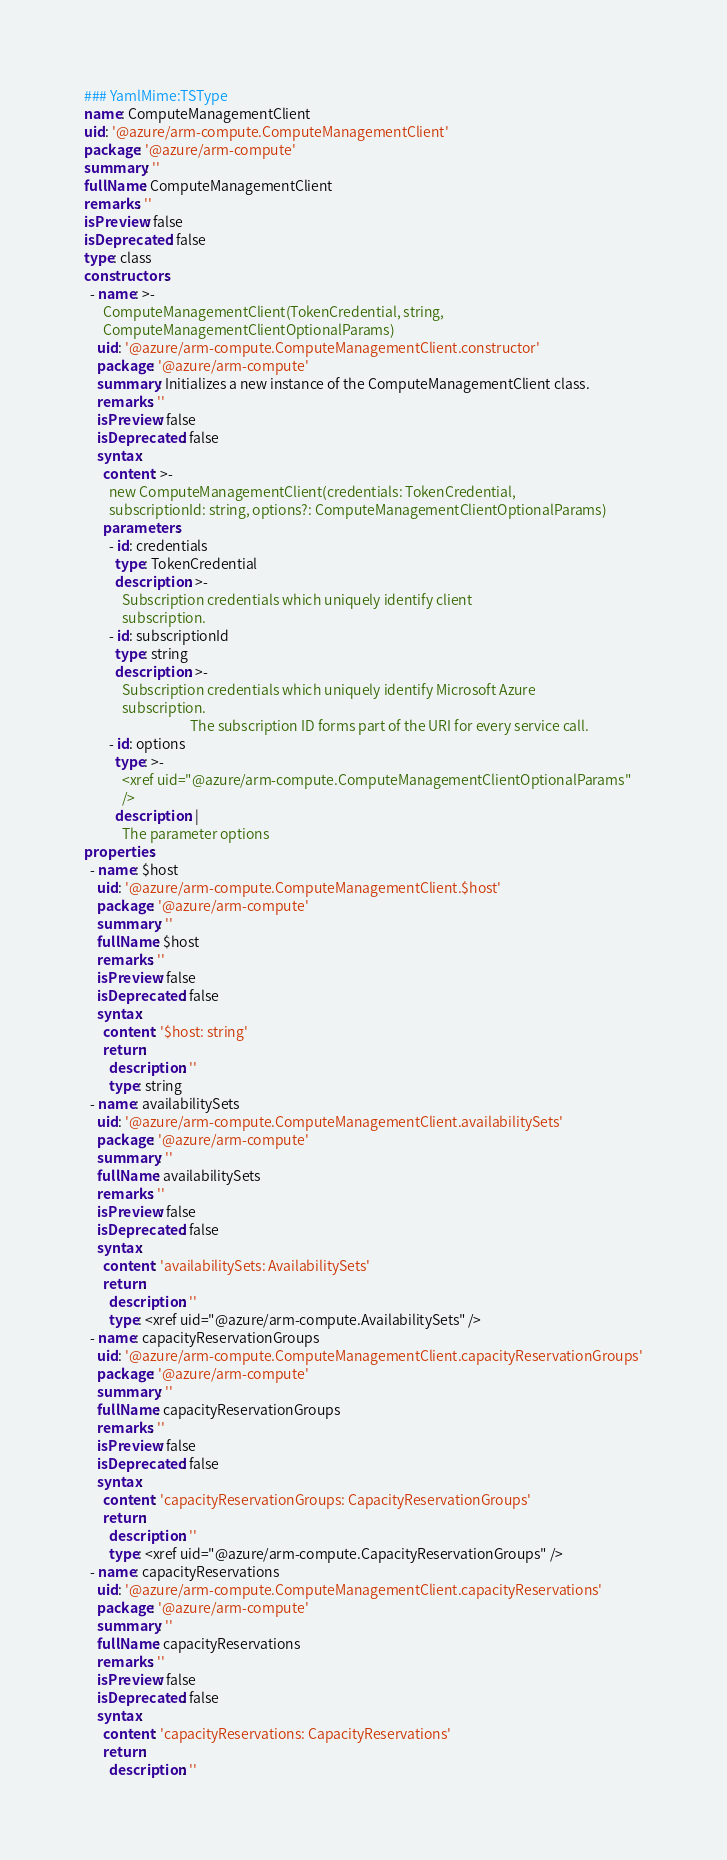Convert code to text. <code><loc_0><loc_0><loc_500><loc_500><_YAML_>### YamlMime:TSType
name: ComputeManagementClient
uid: '@azure/arm-compute.ComputeManagementClient'
package: '@azure/arm-compute'
summary: ''
fullName: ComputeManagementClient
remarks: ''
isPreview: false
isDeprecated: false
type: class
constructors:
  - name: >-
      ComputeManagementClient(TokenCredential, string,
      ComputeManagementClientOptionalParams)
    uid: '@azure/arm-compute.ComputeManagementClient.constructor'
    package: '@azure/arm-compute'
    summary: Initializes a new instance of the ComputeManagementClient class.
    remarks: ''
    isPreview: false
    isDeprecated: false
    syntax:
      content: >-
        new ComputeManagementClient(credentials: TokenCredential,
        subscriptionId: string, options?: ComputeManagementClientOptionalParams)
      parameters:
        - id: credentials
          type: TokenCredential
          description: >-
            Subscription credentials which uniquely identify client
            subscription.
        - id: subscriptionId
          type: string
          description: >-
            Subscription credentials which uniquely identify Microsoft Azure
            subscription.
                                  The subscription ID forms part of the URI for every service call.
        - id: options
          type: >-
            <xref uid="@azure/arm-compute.ComputeManagementClientOptionalParams"
            />
          description: |
            The parameter options
properties:
  - name: $host
    uid: '@azure/arm-compute.ComputeManagementClient.$host'
    package: '@azure/arm-compute'
    summary: ''
    fullName: $host
    remarks: ''
    isPreview: false
    isDeprecated: false
    syntax:
      content: '$host: string'
      return:
        description: ''
        type: string
  - name: availabilitySets
    uid: '@azure/arm-compute.ComputeManagementClient.availabilitySets'
    package: '@azure/arm-compute'
    summary: ''
    fullName: availabilitySets
    remarks: ''
    isPreview: false
    isDeprecated: false
    syntax:
      content: 'availabilitySets: AvailabilitySets'
      return:
        description: ''
        type: <xref uid="@azure/arm-compute.AvailabilitySets" />
  - name: capacityReservationGroups
    uid: '@azure/arm-compute.ComputeManagementClient.capacityReservationGroups'
    package: '@azure/arm-compute'
    summary: ''
    fullName: capacityReservationGroups
    remarks: ''
    isPreview: false
    isDeprecated: false
    syntax:
      content: 'capacityReservationGroups: CapacityReservationGroups'
      return:
        description: ''
        type: <xref uid="@azure/arm-compute.CapacityReservationGroups" />
  - name: capacityReservations
    uid: '@azure/arm-compute.ComputeManagementClient.capacityReservations'
    package: '@azure/arm-compute'
    summary: ''
    fullName: capacityReservations
    remarks: ''
    isPreview: false
    isDeprecated: false
    syntax:
      content: 'capacityReservations: CapacityReservations'
      return:
        description: ''</code> 